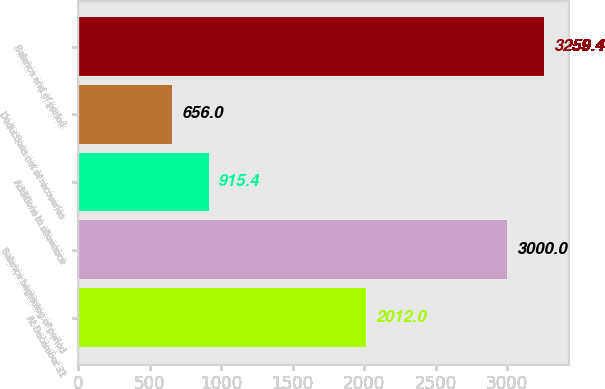Convert chart to OTSL. <chart><loc_0><loc_0><loc_500><loc_500><bar_chart><fcel>At December 31<fcel>Balance beginning of period<fcel>Additions to allowance<fcel>Deductions net of recoveries<fcel>Balance end of period<nl><fcel>2012<fcel>3000<fcel>915.4<fcel>656<fcel>3259.4<nl></chart> 